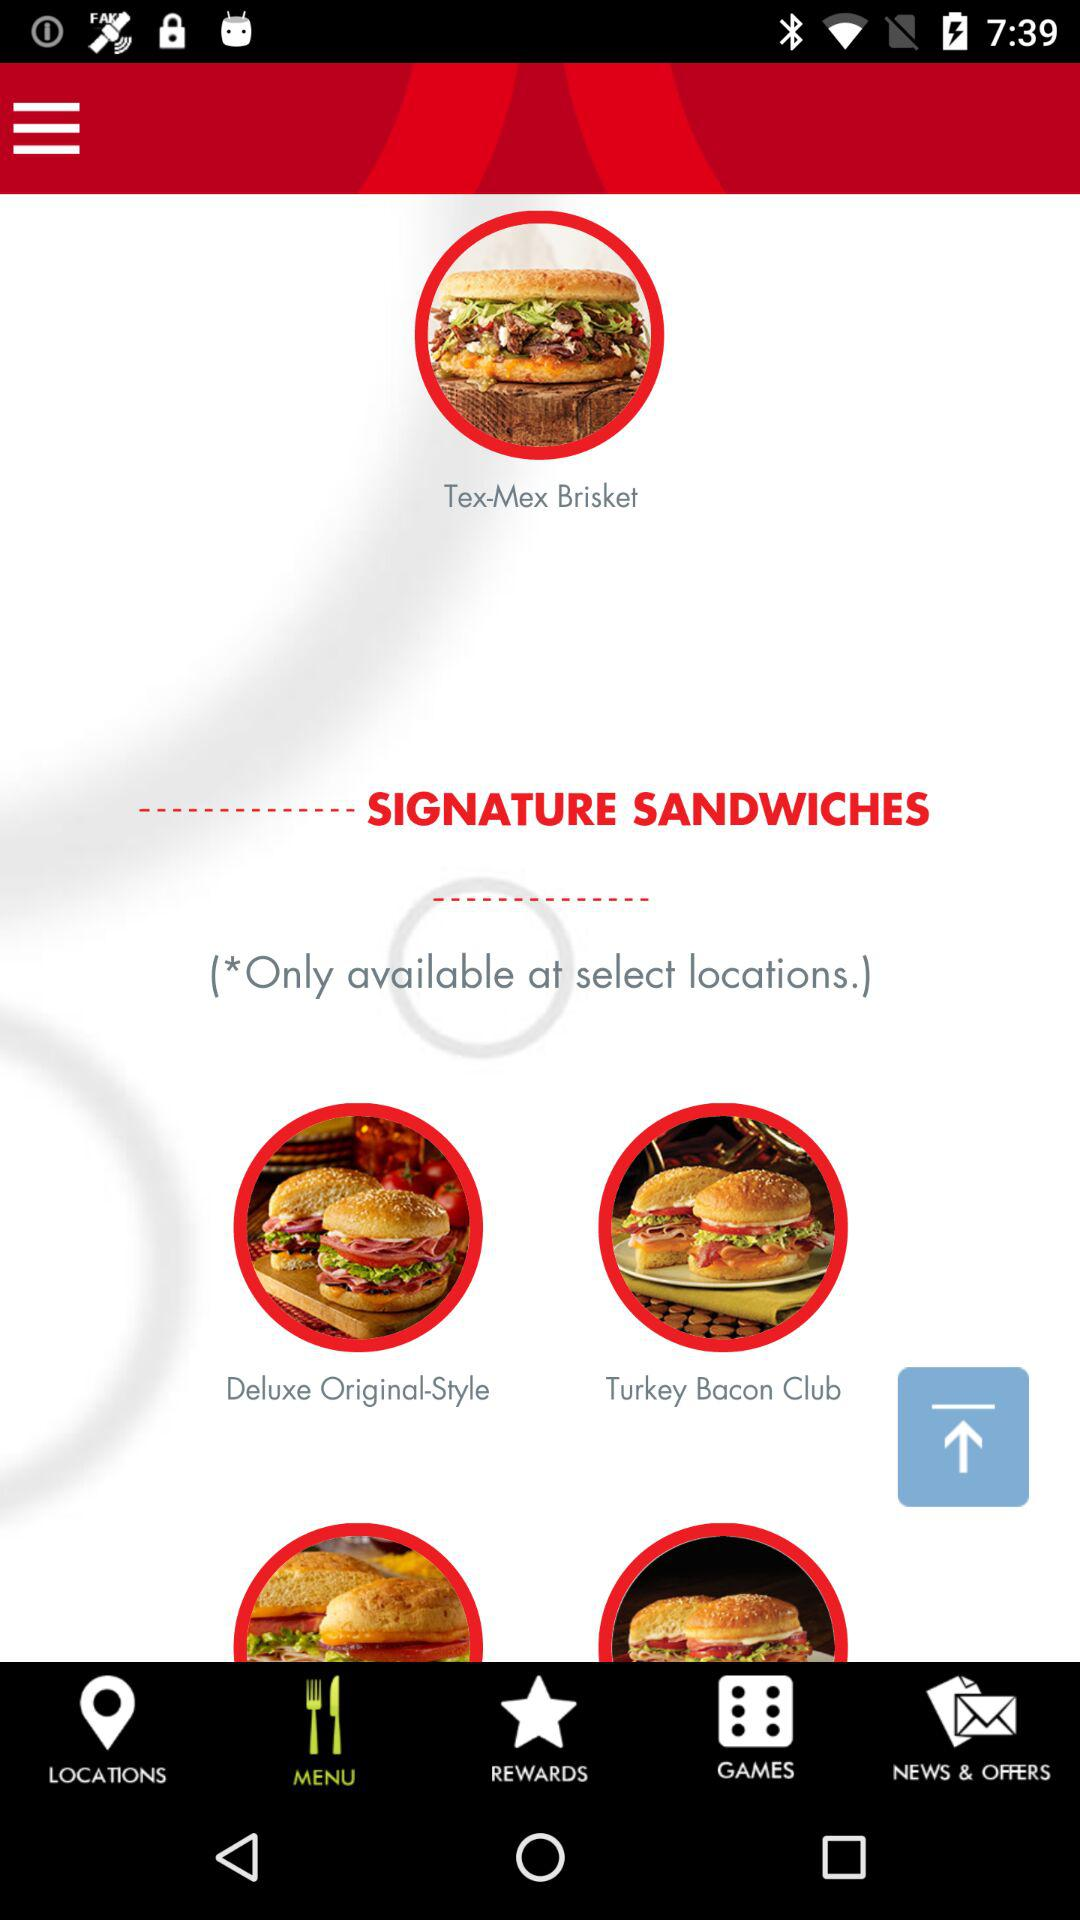Which tab is selected? The selected tab is "MENU". 